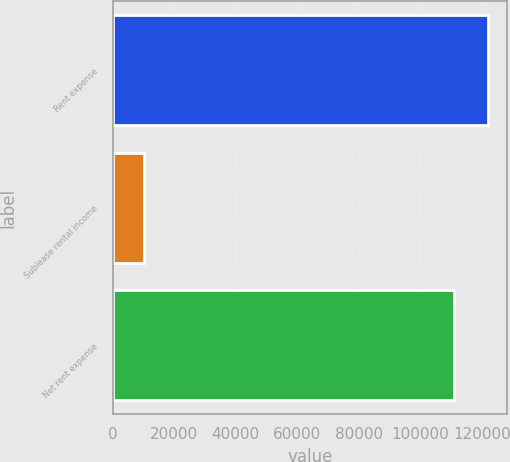<chart> <loc_0><loc_0><loc_500><loc_500><bar_chart><fcel>Rent expense<fcel>Sublease rental income<fcel>Net rent expense<nl><fcel>122000<fcel>10254<fcel>110909<nl></chart> 